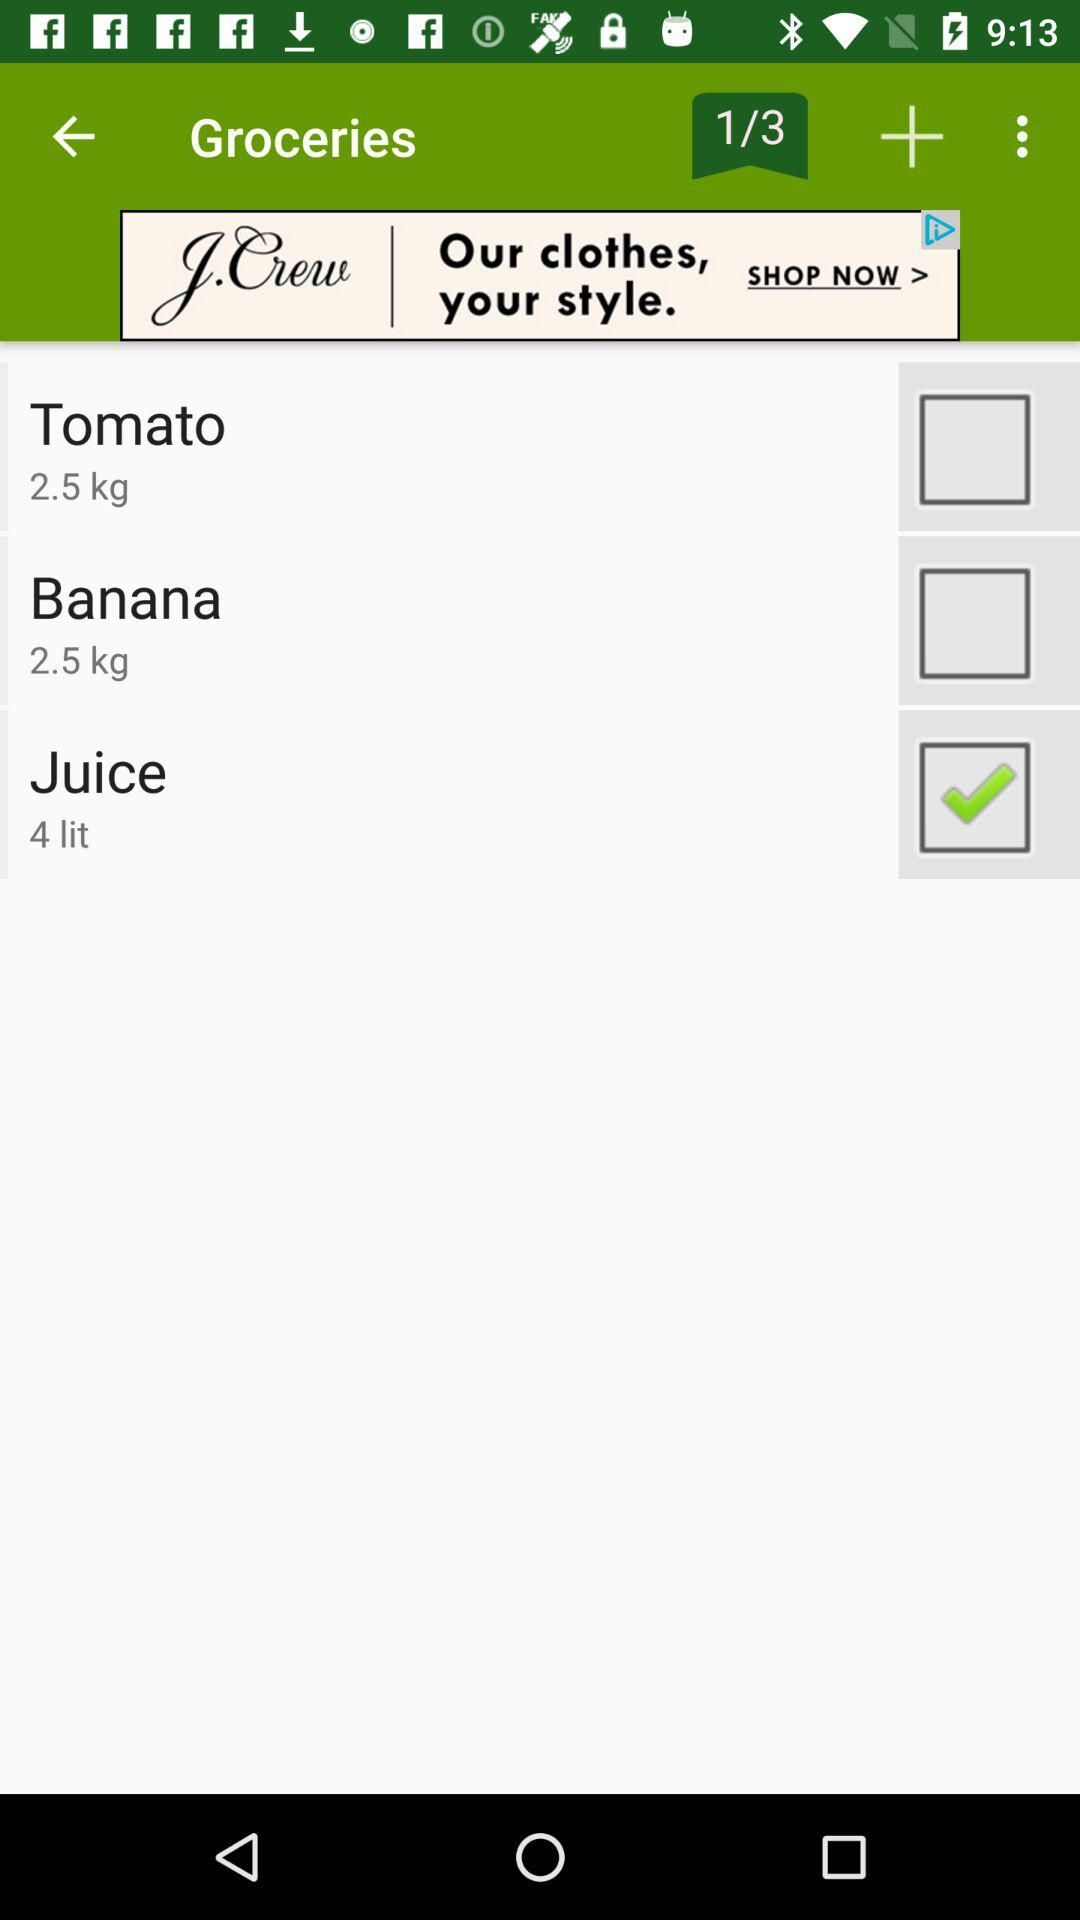What is the weight of bananas? The weight of bananas is 2.5 kg. 